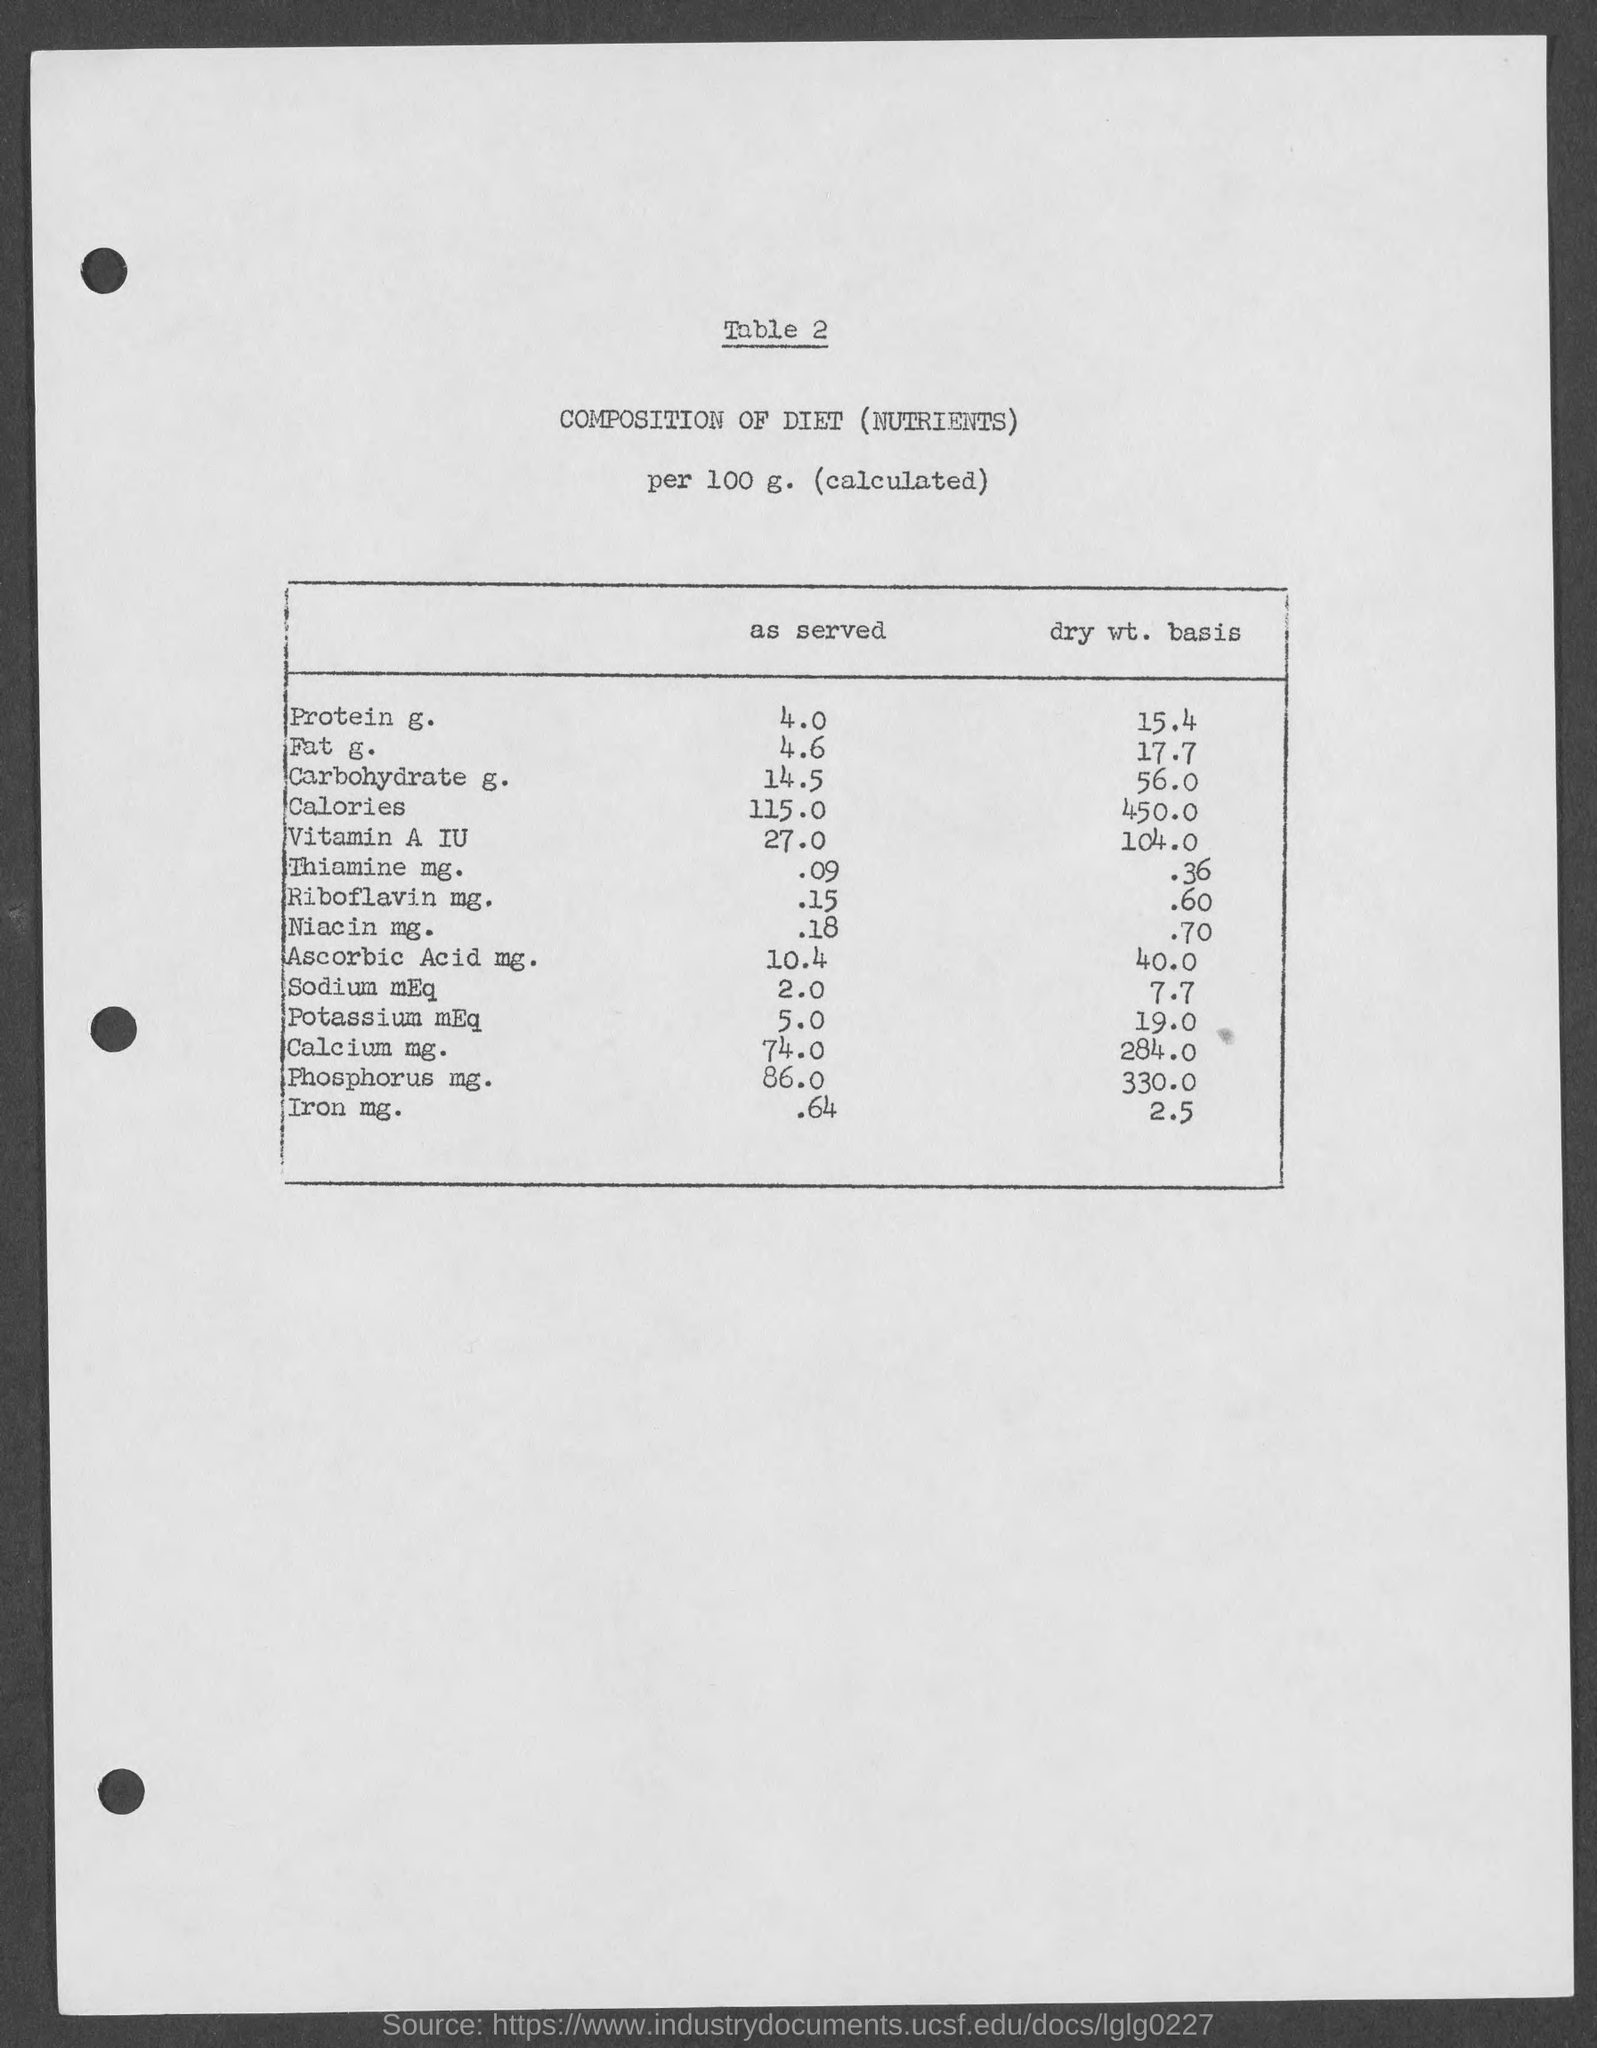Mention a couple of crucial points in this snapshot. The amount of dry weight basis of carbohydrate, as mentioned in the given table, is 56.0 grams. The table mentions that the amount of dry weight basis of fat G is 17.7 grams. The amount of protein in the given table is 4.0 grams. The amount of dry weight basis of protein, as mentioned in the given table, is 15.4. The amount of dry weight basis of calories as mentioned in the given table is 450.0. 